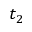<formula> <loc_0><loc_0><loc_500><loc_500>t _ { 2 }</formula> 